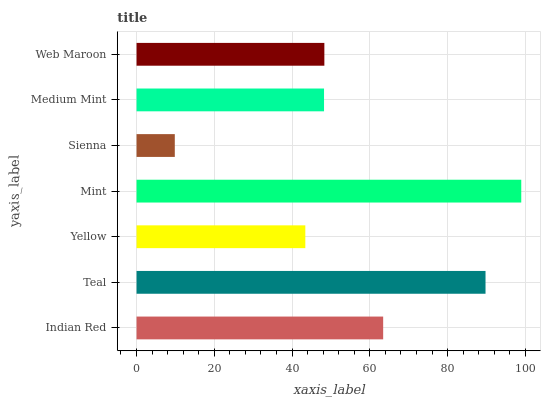Is Sienna the minimum?
Answer yes or no. Yes. Is Mint the maximum?
Answer yes or no. Yes. Is Teal the minimum?
Answer yes or no. No. Is Teal the maximum?
Answer yes or no. No. Is Teal greater than Indian Red?
Answer yes or no. Yes. Is Indian Red less than Teal?
Answer yes or no. Yes. Is Indian Red greater than Teal?
Answer yes or no. No. Is Teal less than Indian Red?
Answer yes or no. No. Is Web Maroon the high median?
Answer yes or no. Yes. Is Web Maroon the low median?
Answer yes or no. Yes. Is Indian Red the high median?
Answer yes or no. No. Is Indian Red the low median?
Answer yes or no. No. 